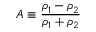<formula> <loc_0><loc_0><loc_500><loc_500>A \equiv \frac { \rho _ { 1 } - \rho _ { 2 } } { \rho _ { 1 } + \rho _ { 2 } }</formula> 